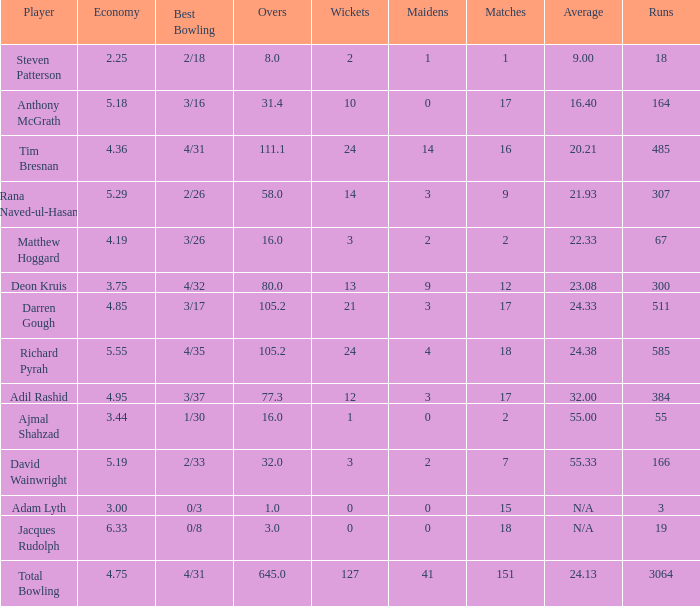What is the lowest Overs with a Run that is 18? 8.0. 